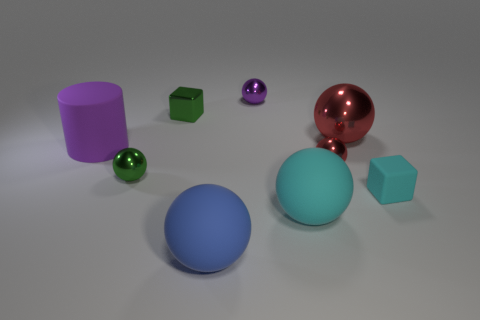Subtract all red balls. How many balls are left? 4 Subtract all cyan matte spheres. How many spheres are left? 5 Subtract all blue spheres. Subtract all red blocks. How many spheres are left? 5 Subtract all cylinders. How many objects are left? 8 Add 5 tiny green metallic spheres. How many tiny green metallic spheres are left? 6 Add 8 cyan things. How many cyan things exist? 10 Subtract 0 gray spheres. How many objects are left? 9 Subtract all small cyan cubes. Subtract all large matte balls. How many objects are left? 6 